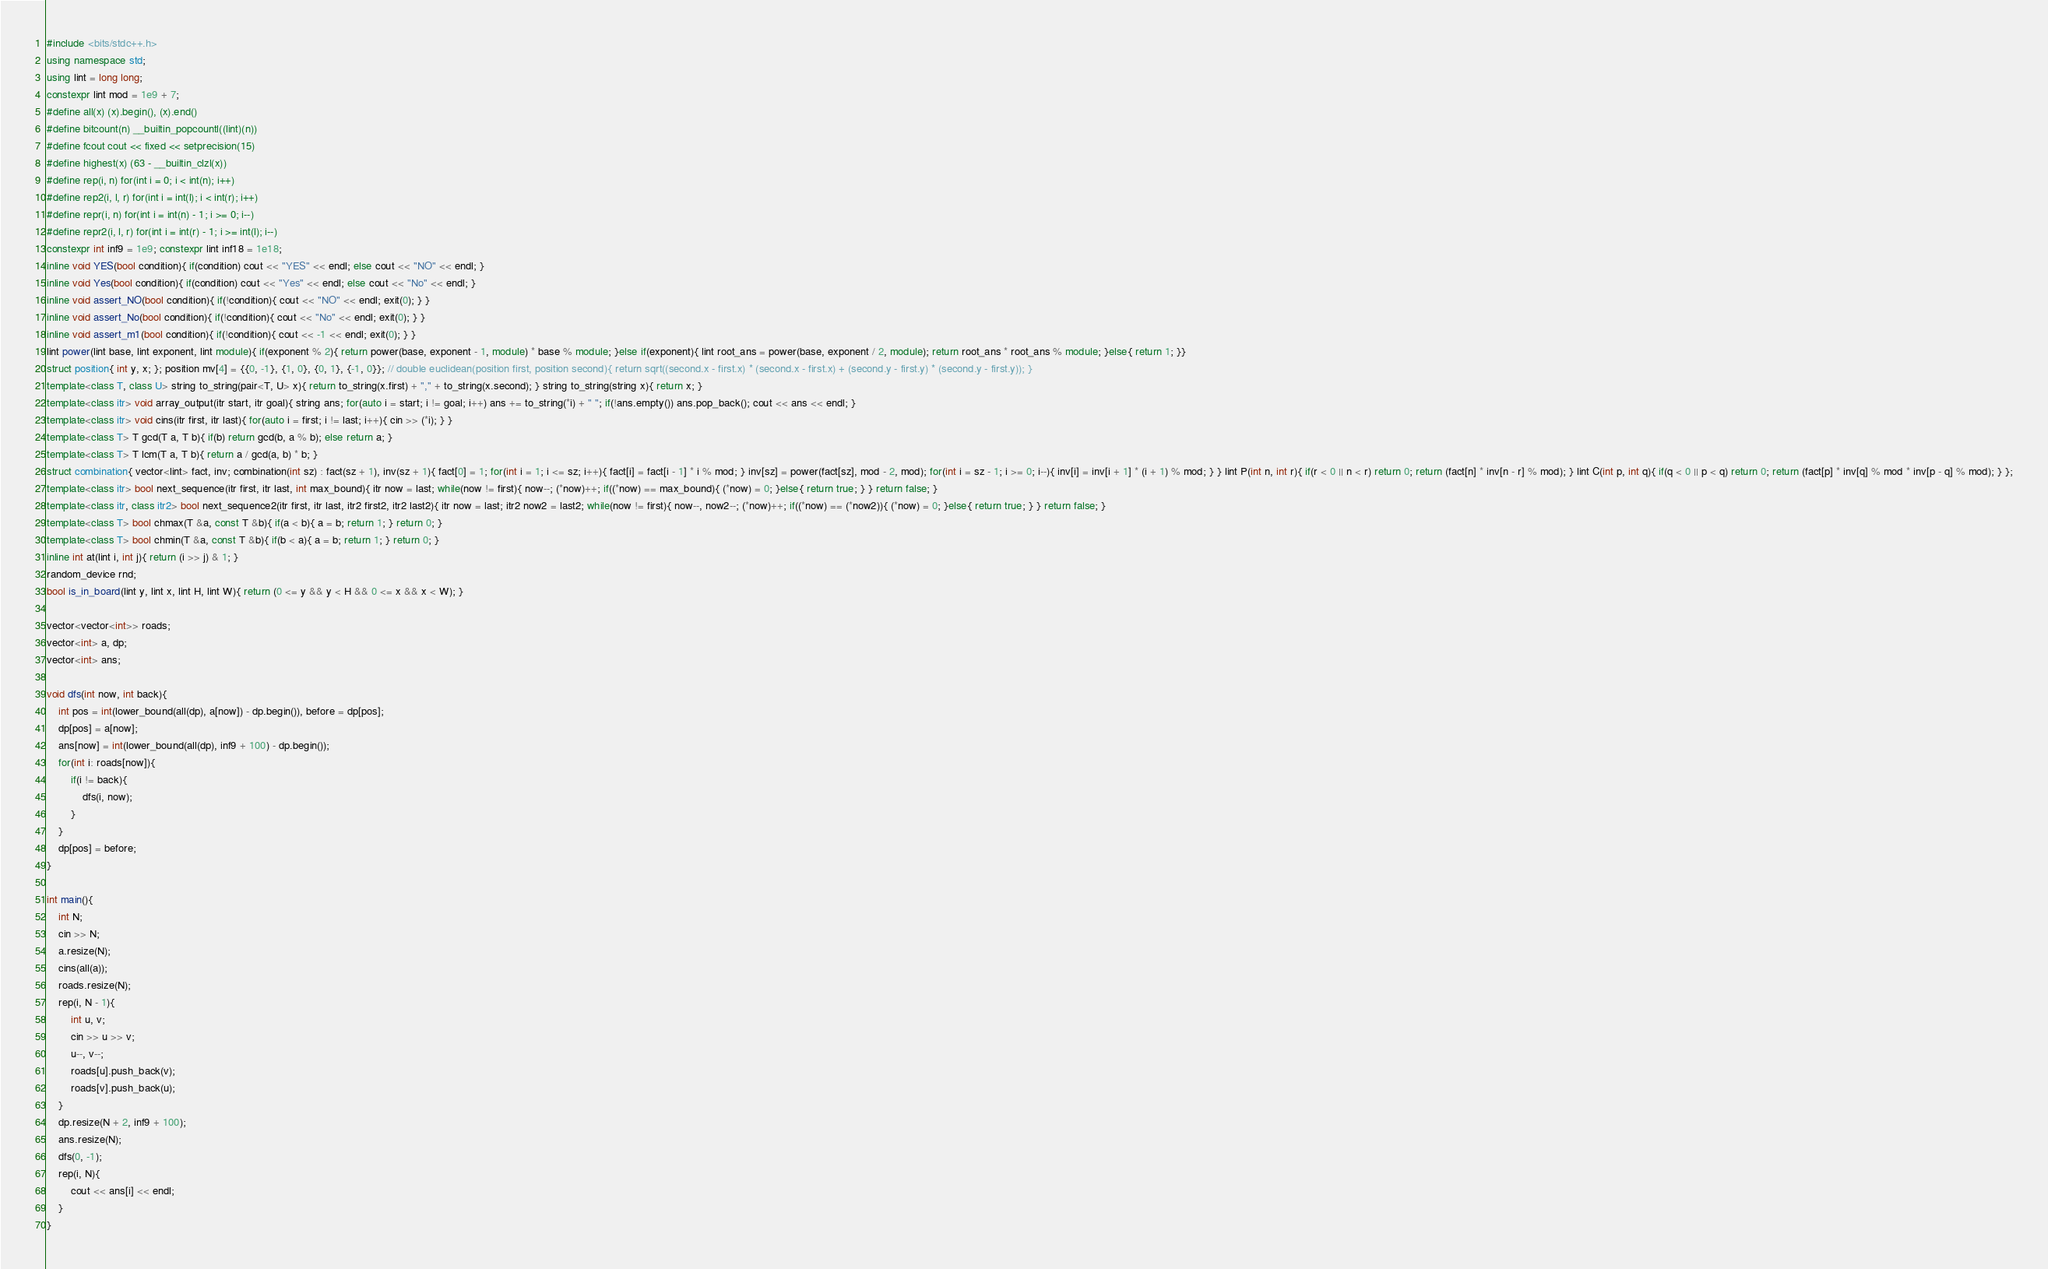<code> <loc_0><loc_0><loc_500><loc_500><_C++_>#include <bits/stdc++.h>
using namespace std;
using lint = long long;
constexpr lint mod = 1e9 + 7;
#define all(x) (x).begin(), (x).end()
#define bitcount(n) __builtin_popcountl((lint)(n))
#define fcout cout << fixed << setprecision(15)
#define highest(x) (63 - __builtin_clzl(x))
#define rep(i, n) for(int i = 0; i < int(n); i++)
#define rep2(i, l, r) for(int i = int(l); i < int(r); i++)
#define repr(i, n) for(int i = int(n) - 1; i >= 0; i--)
#define repr2(i, l, r) for(int i = int(r) - 1; i >= int(l); i--)
constexpr int inf9 = 1e9; constexpr lint inf18 = 1e18;
inline void YES(bool condition){ if(condition) cout << "YES" << endl; else cout << "NO" << endl; }
inline void Yes(bool condition){ if(condition) cout << "Yes" << endl; else cout << "No" << endl; }
inline void assert_NO(bool condition){ if(!condition){ cout << "NO" << endl; exit(0); } }
inline void assert_No(bool condition){ if(!condition){ cout << "No" << endl; exit(0); } }
inline void assert_m1(bool condition){ if(!condition){ cout << -1 << endl; exit(0); } }
lint power(lint base, lint exponent, lint module){ if(exponent % 2){ return power(base, exponent - 1, module) * base % module; }else if(exponent){ lint root_ans = power(base, exponent / 2, module); return root_ans * root_ans % module; }else{ return 1; }}
struct position{ int y, x; }; position mv[4] = {{0, -1}, {1, 0}, {0, 1}, {-1, 0}}; // double euclidean(position first, position second){ return sqrt((second.x - first.x) * (second.x - first.x) + (second.y - first.y) * (second.y - first.y)); }
template<class T, class U> string to_string(pair<T, U> x){ return to_string(x.first) + "," + to_string(x.second); } string to_string(string x){ return x; }
template<class itr> void array_output(itr start, itr goal){ string ans; for(auto i = start; i != goal; i++) ans += to_string(*i) + " "; if(!ans.empty()) ans.pop_back(); cout << ans << endl; }
template<class itr> void cins(itr first, itr last){ for(auto i = first; i != last; i++){ cin >> (*i); } }
template<class T> T gcd(T a, T b){ if(b) return gcd(b, a % b); else return a; }
template<class T> T lcm(T a, T b){ return a / gcd(a, b) * b; }
struct combination{ vector<lint> fact, inv; combination(int sz) : fact(sz + 1), inv(sz + 1){ fact[0] = 1; for(int i = 1; i <= sz; i++){ fact[i] = fact[i - 1] * i % mod; } inv[sz] = power(fact[sz], mod - 2, mod); for(int i = sz - 1; i >= 0; i--){ inv[i] = inv[i + 1] * (i + 1) % mod; } } lint P(int n, int r){ if(r < 0 || n < r) return 0; return (fact[n] * inv[n - r] % mod); } lint C(int p, int q){ if(q < 0 || p < q) return 0; return (fact[p] * inv[q] % mod * inv[p - q] % mod); } };
template<class itr> bool next_sequence(itr first, itr last, int max_bound){ itr now = last; while(now != first){ now--; (*now)++; if((*now) == max_bound){ (*now) = 0; }else{ return true; } } return false; }
template<class itr, class itr2> bool next_sequence2(itr first, itr last, itr2 first2, itr2 last2){ itr now = last; itr2 now2 = last2; while(now != first){ now--, now2--; (*now)++; if((*now) == (*now2)){ (*now) = 0; }else{ return true; } } return false; }
template<class T> bool chmax(T &a, const T &b){ if(a < b){ a = b; return 1; } return 0; }
template<class T> bool chmin(T &a, const T &b){ if(b < a){ a = b; return 1; } return 0; }
inline int at(lint i, int j){ return (i >> j) & 1; }
random_device rnd;
bool is_in_board(lint y, lint x, lint H, lint W){ return (0 <= y && y < H && 0 <= x && x < W); }

vector<vector<int>> roads;
vector<int> a, dp;
vector<int> ans;

void dfs(int now, int back){
    int pos = int(lower_bound(all(dp), a[now]) - dp.begin()), before = dp[pos];
    dp[pos] = a[now];
    ans[now] = int(lower_bound(all(dp), inf9 + 100) - dp.begin());
    for(int i: roads[now]){
        if(i != back){
            dfs(i, now);
        }
    }
    dp[pos] = before;
}

int main(){
    int N;
    cin >> N;
    a.resize(N);
    cins(all(a));
    roads.resize(N);
    rep(i, N - 1){
        int u, v;
        cin >> u >> v;
        u--, v--;
        roads[u].push_back(v);
        roads[v].push_back(u);
    }
    dp.resize(N + 2, inf9 + 100);
    ans.resize(N);
    dfs(0, -1);
    rep(i, N){
        cout << ans[i] << endl;
    }
}
</code> 